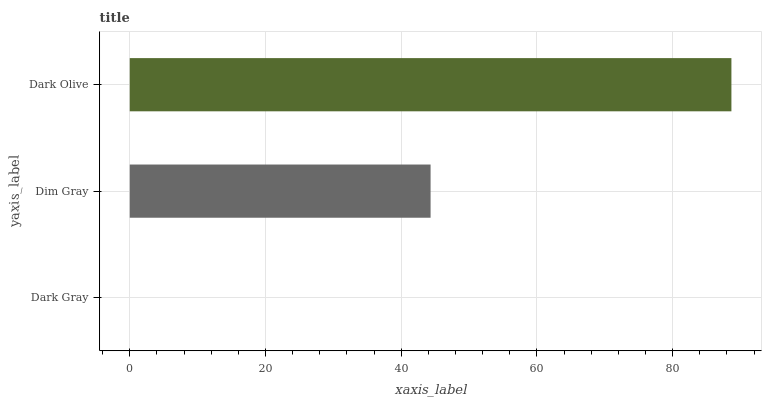Is Dark Gray the minimum?
Answer yes or no. Yes. Is Dark Olive the maximum?
Answer yes or no. Yes. Is Dim Gray the minimum?
Answer yes or no. No. Is Dim Gray the maximum?
Answer yes or no. No. Is Dim Gray greater than Dark Gray?
Answer yes or no. Yes. Is Dark Gray less than Dim Gray?
Answer yes or no. Yes. Is Dark Gray greater than Dim Gray?
Answer yes or no. No. Is Dim Gray less than Dark Gray?
Answer yes or no. No. Is Dim Gray the high median?
Answer yes or no. Yes. Is Dim Gray the low median?
Answer yes or no. Yes. Is Dark Gray the high median?
Answer yes or no. No. Is Dark Gray the low median?
Answer yes or no. No. 